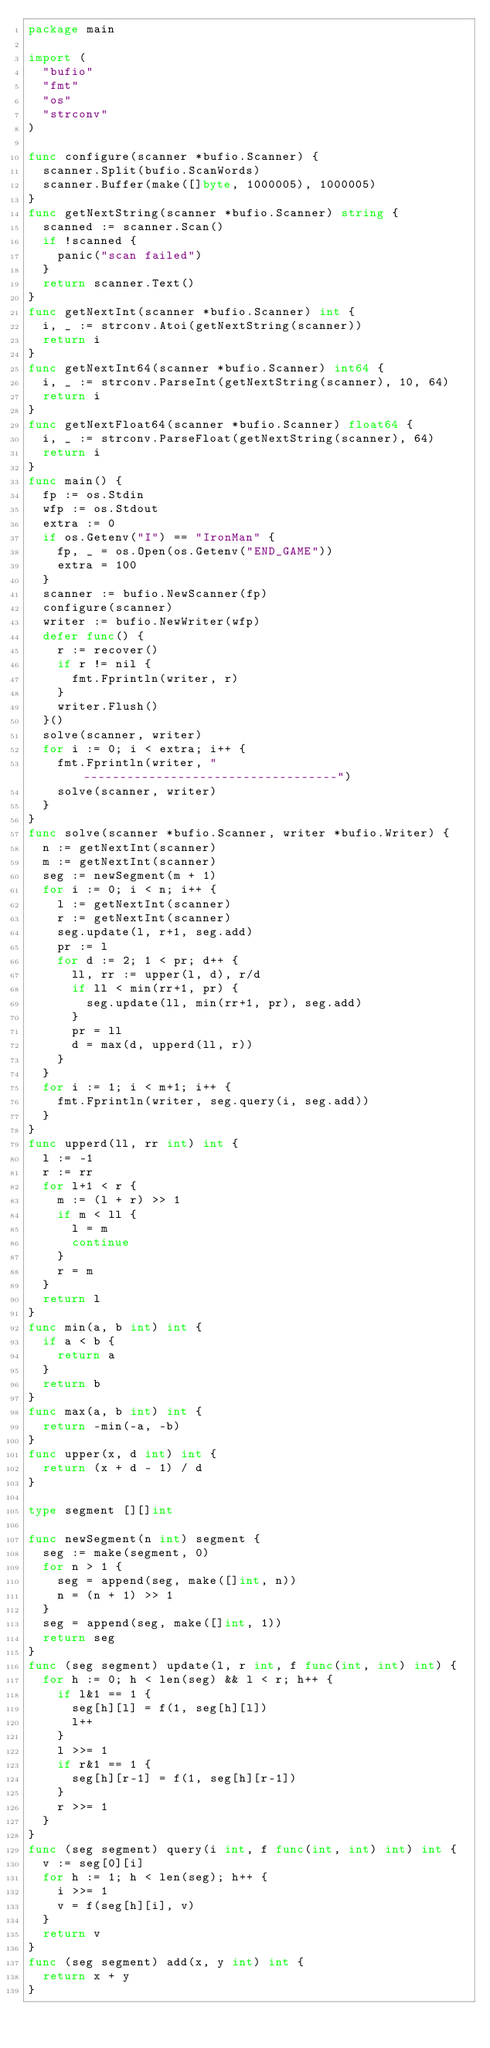<code> <loc_0><loc_0><loc_500><loc_500><_Go_>package main

import (
	"bufio"
	"fmt"
	"os"
	"strconv"
)

func configure(scanner *bufio.Scanner) {
	scanner.Split(bufio.ScanWords)
	scanner.Buffer(make([]byte, 1000005), 1000005)
}
func getNextString(scanner *bufio.Scanner) string {
	scanned := scanner.Scan()
	if !scanned {
		panic("scan failed")
	}
	return scanner.Text()
}
func getNextInt(scanner *bufio.Scanner) int {
	i, _ := strconv.Atoi(getNextString(scanner))
	return i
}
func getNextInt64(scanner *bufio.Scanner) int64 {
	i, _ := strconv.ParseInt(getNextString(scanner), 10, 64)
	return i
}
func getNextFloat64(scanner *bufio.Scanner) float64 {
	i, _ := strconv.ParseFloat(getNextString(scanner), 64)
	return i
}
func main() {
	fp := os.Stdin
	wfp := os.Stdout
	extra := 0
	if os.Getenv("I") == "IronMan" {
		fp, _ = os.Open(os.Getenv("END_GAME"))
		extra = 100
	}
	scanner := bufio.NewScanner(fp)
	configure(scanner)
	writer := bufio.NewWriter(wfp)
	defer func() {
		r := recover()
		if r != nil {
			fmt.Fprintln(writer, r)
		}
		writer.Flush()
	}()
	solve(scanner, writer)
	for i := 0; i < extra; i++ {
		fmt.Fprintln(writer, "-----------------------------------")
		solve(scanner, writer)
	}
}
func solve(scanner *bufio.Scanner, writer *bufio.Writer) {
	n := getNextInt(scanner)
	m := getNextInt(scanner)
	seg := newSegment(m + 1)
	for i := 0; i < n; i++ {
		l := getNextInt(scanner)
		r := getNextInt(scanner)
		seg.update(l, r+1, seg.add)
		pr := l
		for d := 2; 1 < pr; d++ {
			ll, rr := upper(l, d), r/d
			if ll < min(rr+1, pr) {
				seg.update(ll, min(rr+1, pr), seg.add)
			}
			pr = ll
			d = max(d, upperd(ll, r))
		}
	}
	for i := 1; i < m+1; i++ {
		fmt.Fprintln(writer, seg.query(i, seg.add))
	}
}
func upperd(ll, rr int) int {
	l := -1
	r := rr
	for l+1 < r {
		m := (l + r) >> 1
		if m < ll {
			l = m
			continue
		}
		r = m
	}
	return l
}
func min(a, b int) int {
	if a < b {
		return a
	}
	return b
}
func max(a, b int) int {
	return -min(-a, -b)
}
func upper(x, d int) int {
	return (x + d - 1) / d
}

type segment [][]int

func newSegment(n int) segment {
	seg := make(segment, 0)
	for n > 1 {
		seg = append(seg, make([]int, n))
		n = (n + 1) >> 1
	}
	seg = append(seg, make([]int, 1))
	return seg
}
func (seg segment) update(l, r int, f func(int, int) int) {
	for h := 0; h < len(seg) && l < r; h++ {
		if l&1 == 1 {
			seg[h][l] = f(1, seg[h][l])
			l++
		}
		l >>= 1
		if r&1 == 1 {
			seg[h][r-1] = f(1, seg[h][r-1])
		}
		r >>= 1
	}
}
func (seg segment) query(i int, f func(int, int) int) int {
	v := seg[0][i]
	for h := 1; h < len(seg); h++ {
		i >>= 1
		v = f(seg[h][i], v)
	}
	return v
}
func (seg segment) add(x, y int) int {
	return x + y
}
</code> 